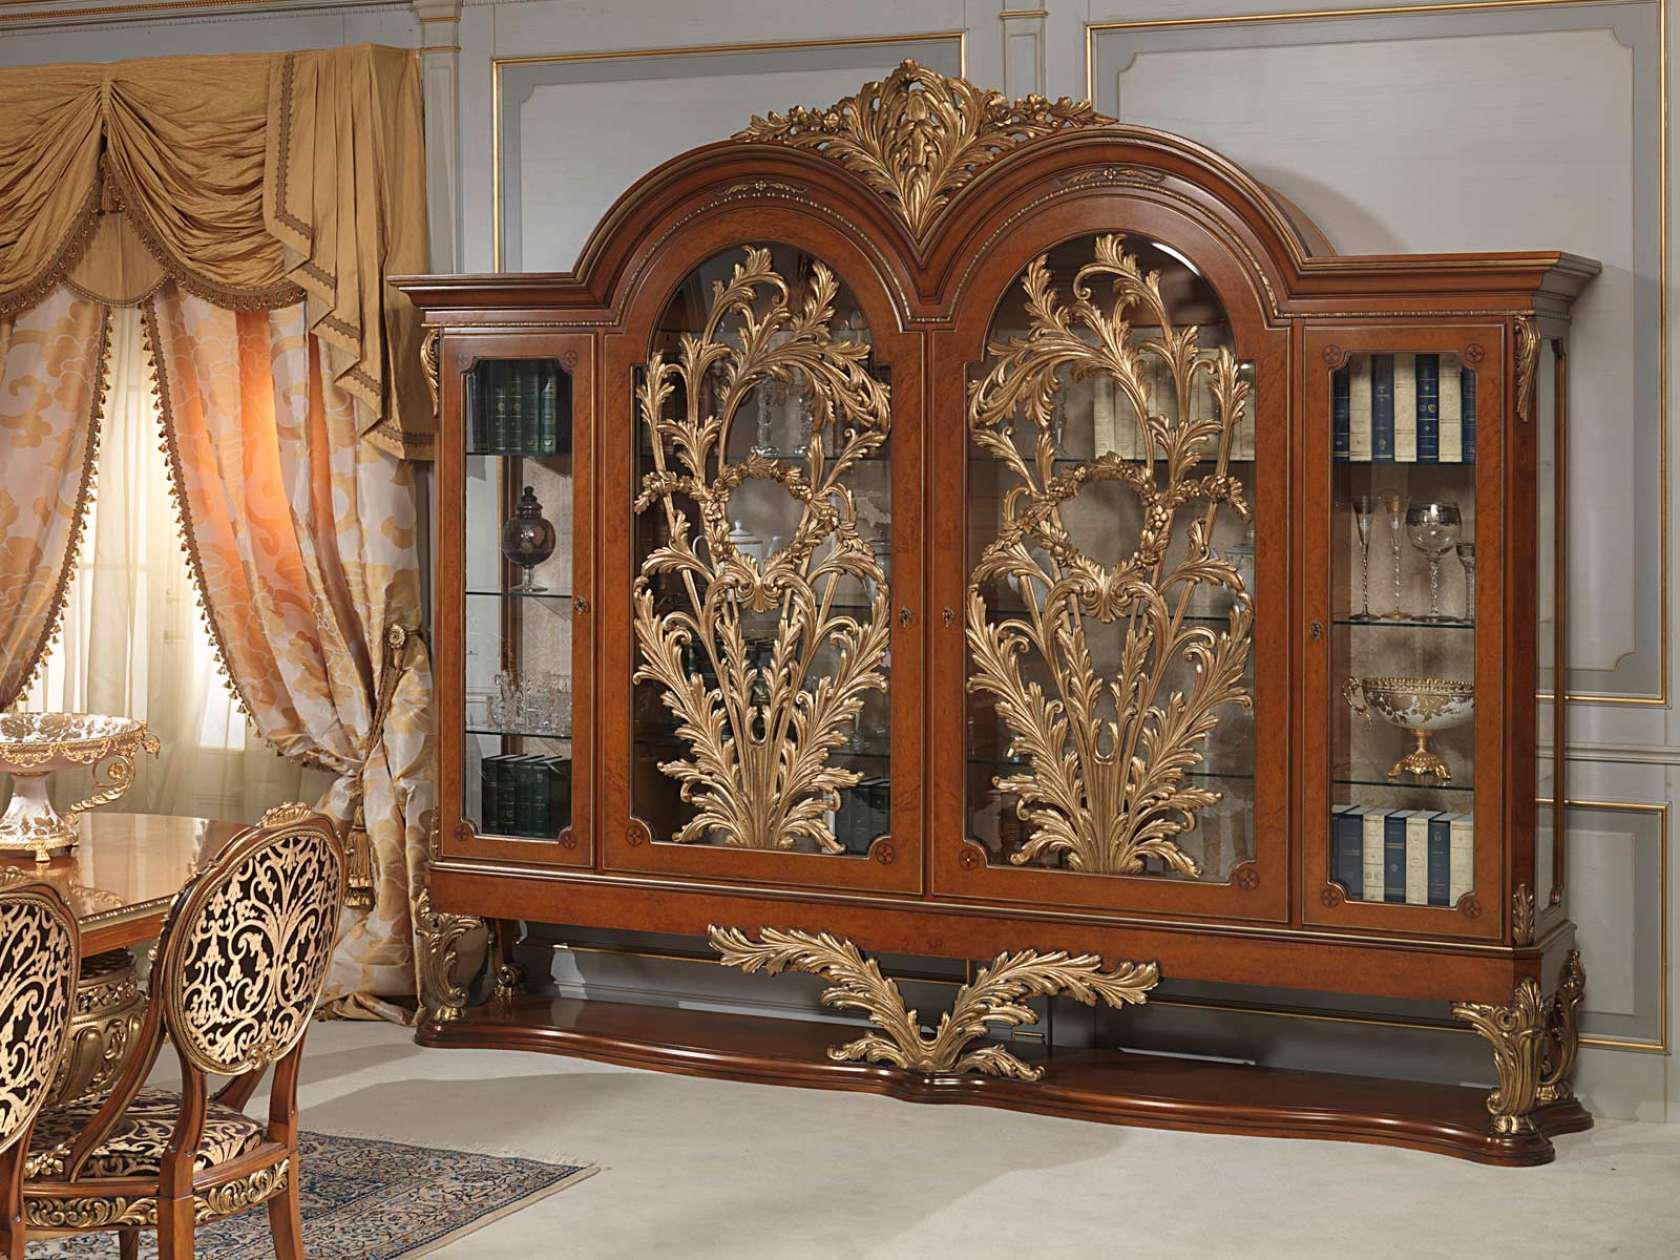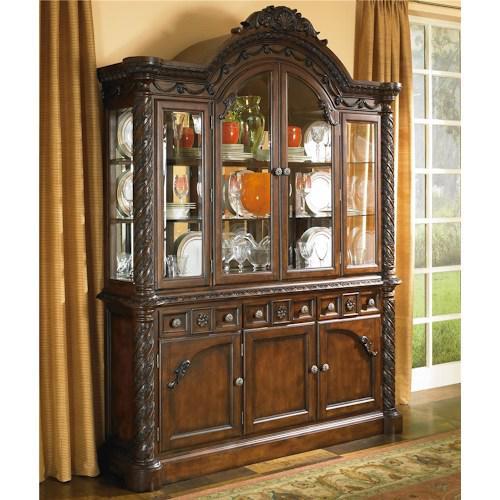The first image is the image on the left, the second image is the image on the right. For the images shown, is this caption "Two dark hutches have solid wooden doors at the bottom and sit flush to the floor." true? Answer yes or no. No. 